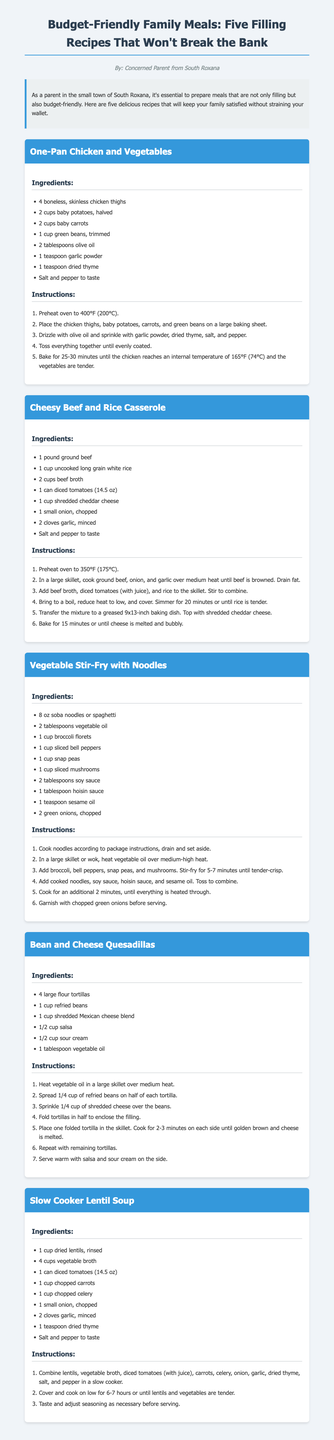What is the title of the document? The title is prominently displayed at the top of the document.
Answer: Budget-Friendly Family Meals: Five Filling Recipes That Won't Break the Bank Who is the author of the recipes? The author's name is listed right below the title in the document.
Answer: Concerned Parent from South Roxana How many recipes are included in the document? The introduction mentions the number of recipes provided.
Answer: Five What temperature should the oven be preheated to for the Cheesy Beef and Rice Casserole? The instructions for Cheesy Beef and Rice Casserole specify the temperature for preheating.
Answer: 350°F (175°C) What ingredient is used in the Vegetable Stir-Fry that adds flavor and richness? The ingredients list for Vegetable Stir-Fry includes additional flavors.
Answer: Soy sauce Which recipe includes lentils as a primary ingredient? The ingredient list for one of the recipes directly mentions lentils.
Answer: Slow Cooker Lentil Soup What is the main cooking method used for the Bean and Cheese Quesadillas? The cooking instructions for this recipe describe the method used.
Answer: Skillet How long should the Slow Cooker Lentil Soup be cooked on low? The instructions for cooking the soup provide specific duration details.
Answer: 6-7 hours 